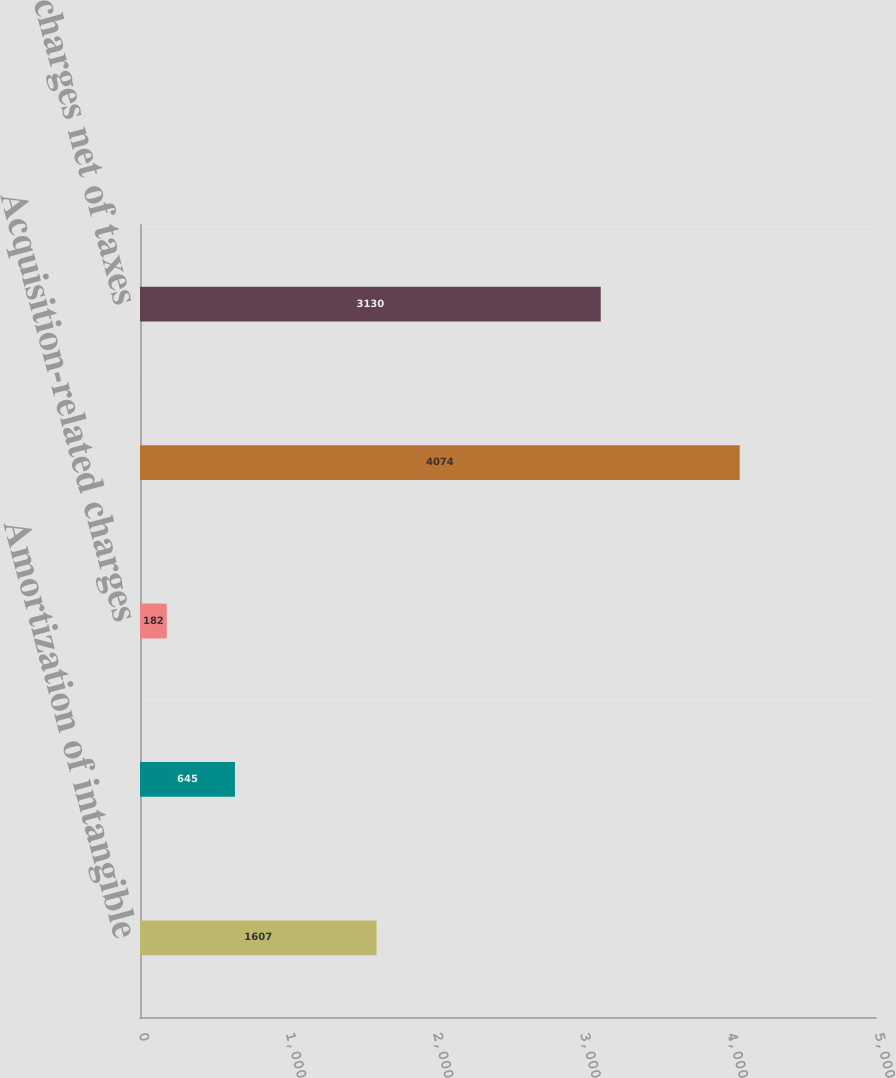Convert chart to OTSL. <chart><loc_0><loc_0><loc_500><loc_500><bar_chart><fcel>Amortization of intangible<fcel>Restructuring charges<fcel>Acquisition-related charges<fcel>Total charges before taxes<fcel>Total charges net of taxes<nl><fcel>1607<fcel>645<fcel>182<fcel>4074<fcel>3130<nl></chart> 